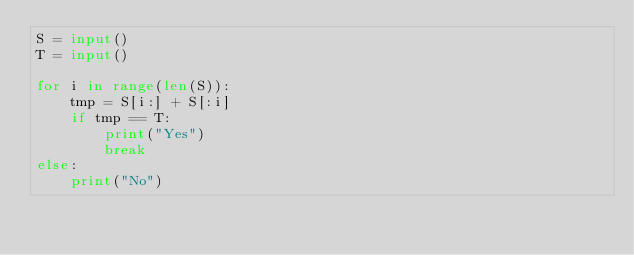Convert code to text. <code><loc_0><loc_0><loc_500><loc_500><_Python_>S = input()
T = input()

for i in range(len(S)):
    tmp = S[i:] + S[:i]
    if tmp == T:
        print("Yes")
        break
else:
    print("No")
</code> 